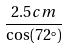<formula> <loc_0><loc_0><loc_500><loc_500>\frac { 2 . 5 c m } { \cos ( 7 2 ^ { \circ } ) }</formula> 